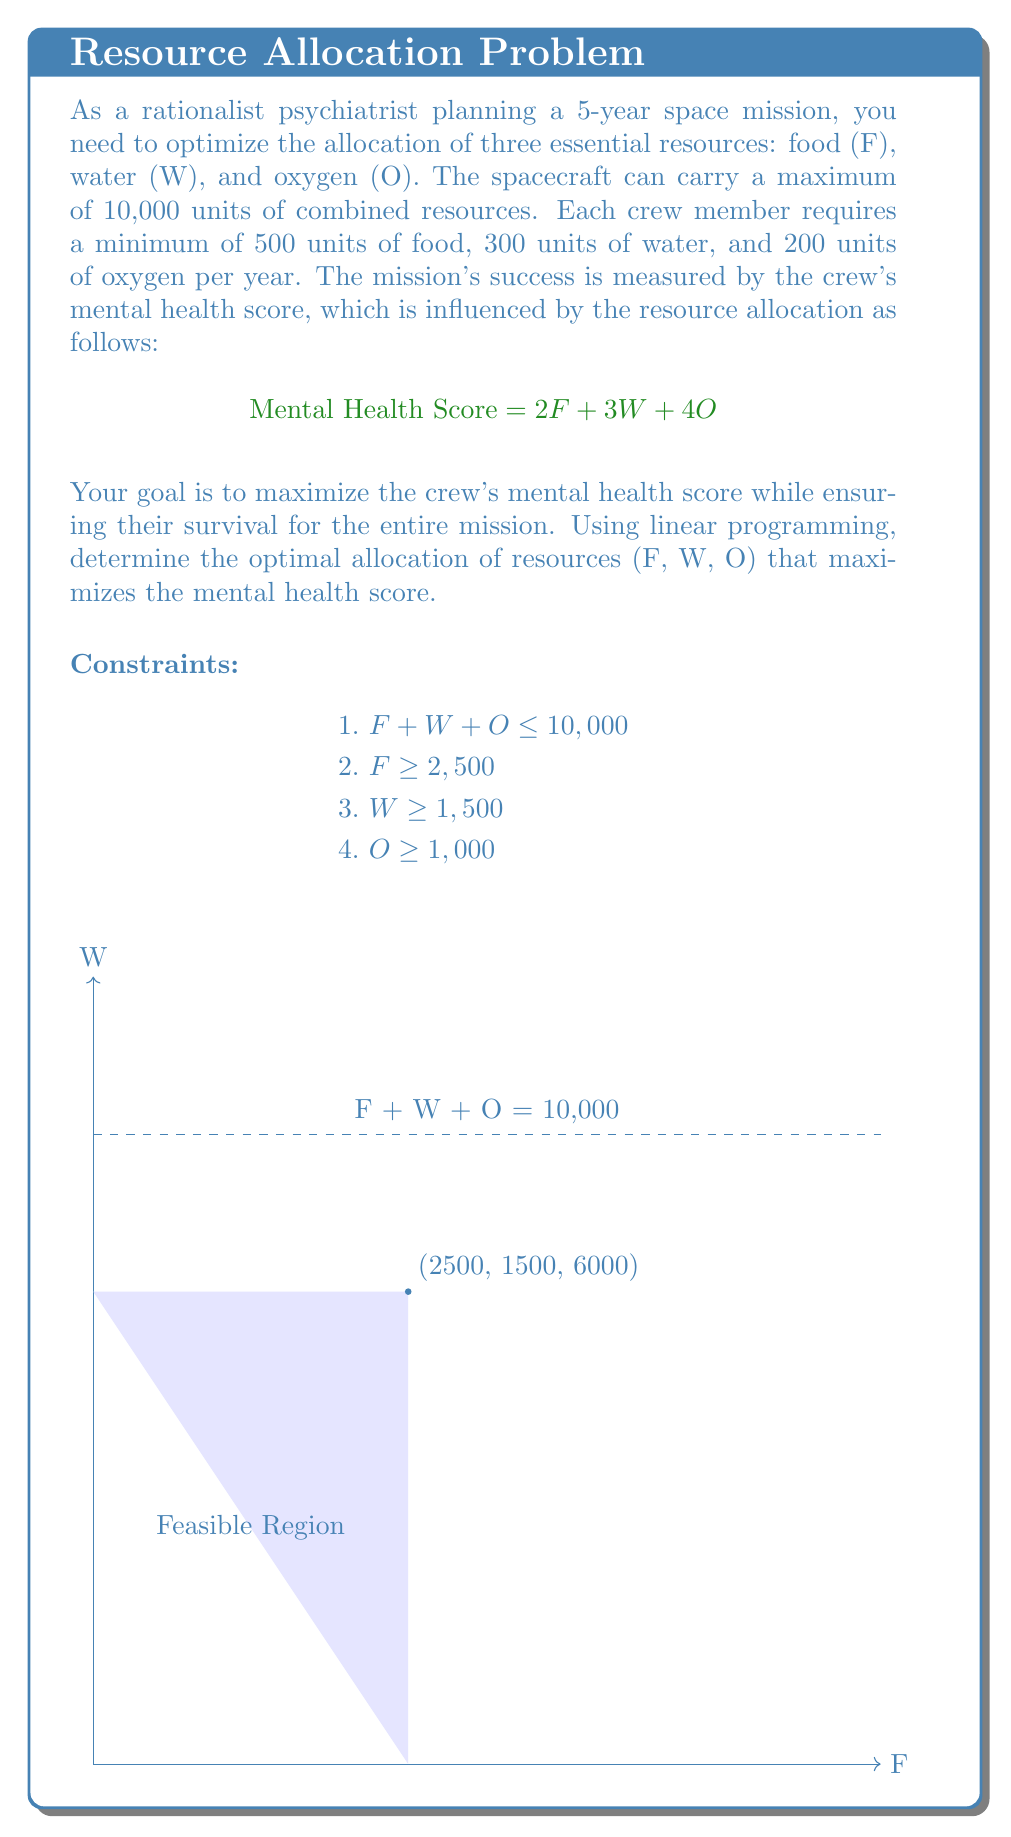What is the answer to this math problem? Let's solve this linear programming problem step by step:

1. Define the objective function:
   Maximize Z = 2F + 3W + 4O

2. List the constraints:
   F + W + O ≤ 10,000
   F ≥ 2,500
   W ≥ 1,500
   O ≥ 1,000

3. Since we're maximizing a linear function subject to linear constraints, the optimal solution will be at one of the extreme points of the feasible region.

4. The extreme points are the intersections of the constraint boundaries. However, we can eliminate some points by observing that we should use all available resources to maximize the mental health score.

5. Therefore, we can replace the inequality in the first constraint with an equality:
   F + W + O = 10,000

6. Now, we have three variables and one equation. We need to find the optimal combination that satisfies all constraints and maximizes Z.

7. Given that O contributes the most to the mental health score (coefficient 4), we should allocate as much as possible to O while satisfying the other constraints.

8. The minimum requirements for F and W are 2,500 and 1,500 respectively. Allocating these minimums leaves us with:
   10,000 - 2,500 - 1,500 = 6,000 units for O

9. Therefore, the optimal allocation is:
   F = 2,500
   W = 1,500
   O = 6,000

10. We can verify that this satisfies all constraints:
    2,500 + 1,500 + 6,000 = 10,000 ≤ 10,000
    2,500 ≥ 2,500
    1,500 ≥ 1,500
    6,000 ≥ 1,000

11. The maximum mental health score is:
    Z = 2(2,500) + 3(1,500) + 4(6,000) = 5,000 + 4,500 + 24,000 = 33,500
Answer: F = 2,500, W = 1,500, O = 6,000; Max Mental Health Score = 33,500 